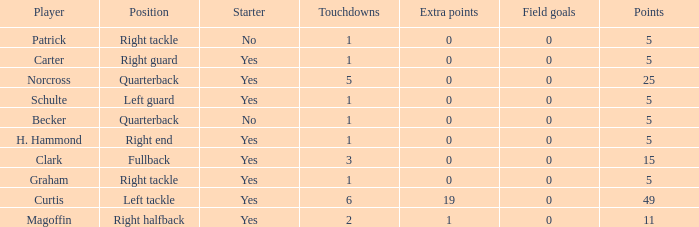Would you be able to parse every entry in this table? {'header': ['Player', 'Position', 'Starter', 'Touchdowns', 'Extra points', 'Field goals', 'Points'], 'rows': [['Patrick', 'Right tackle', 'No', '1', '0', '0', '5'], ['Carter', 'Right guard', 'Yes', '1', '0', '0', '5'], ['Norcross', 'Quarterback', 'Yes', '5', '0', '0', '25'], ['Schulte', 'Left guard', 'Yes', '1', '0', '0', '5'], ['Becker', 'Quarterback', 'No', '1', '0', '0', '5'], ['H. Hammond', 'Right end', 'Yes', '1', '0', '0', '5'], ['Clark', 'Fullback', 'Yes', '3', '0', '0', '15'], ['Graham', 'Right tackle', 'Yes', '1', '0', '0', '5'], ['Curtis', 'Left tackle', 'Yes', '6', '19', '0', '49'], ['Magoffin', 'Right halfback', 'Yes', '2', '1', '0', '11']]} Name the most touchdowns for becker  1.0. 